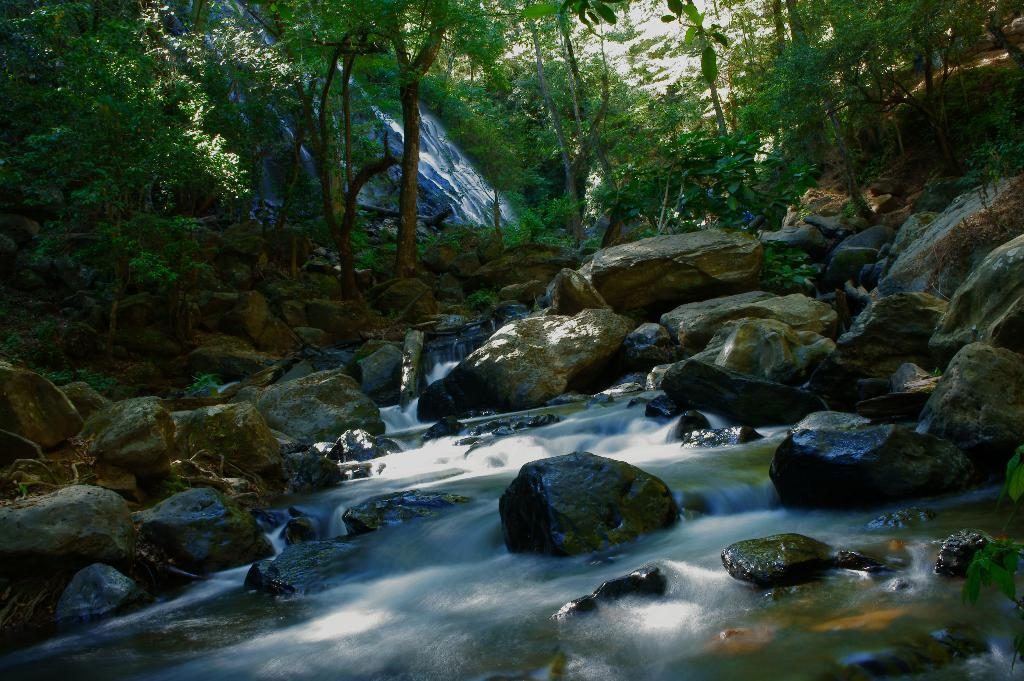Where was the picture taken? The picture was taken outside. What can be seen in the foreground of the image? There is a water body and rocks in the foreground. What is visible in the background of the image? There is a waterfall, plants, and trees in the background. Where can someone find a pocket in the image? There are no pockets visible in the image, as it features a natural landscape with a water body, rocks, waterfall, plants, and trees. 